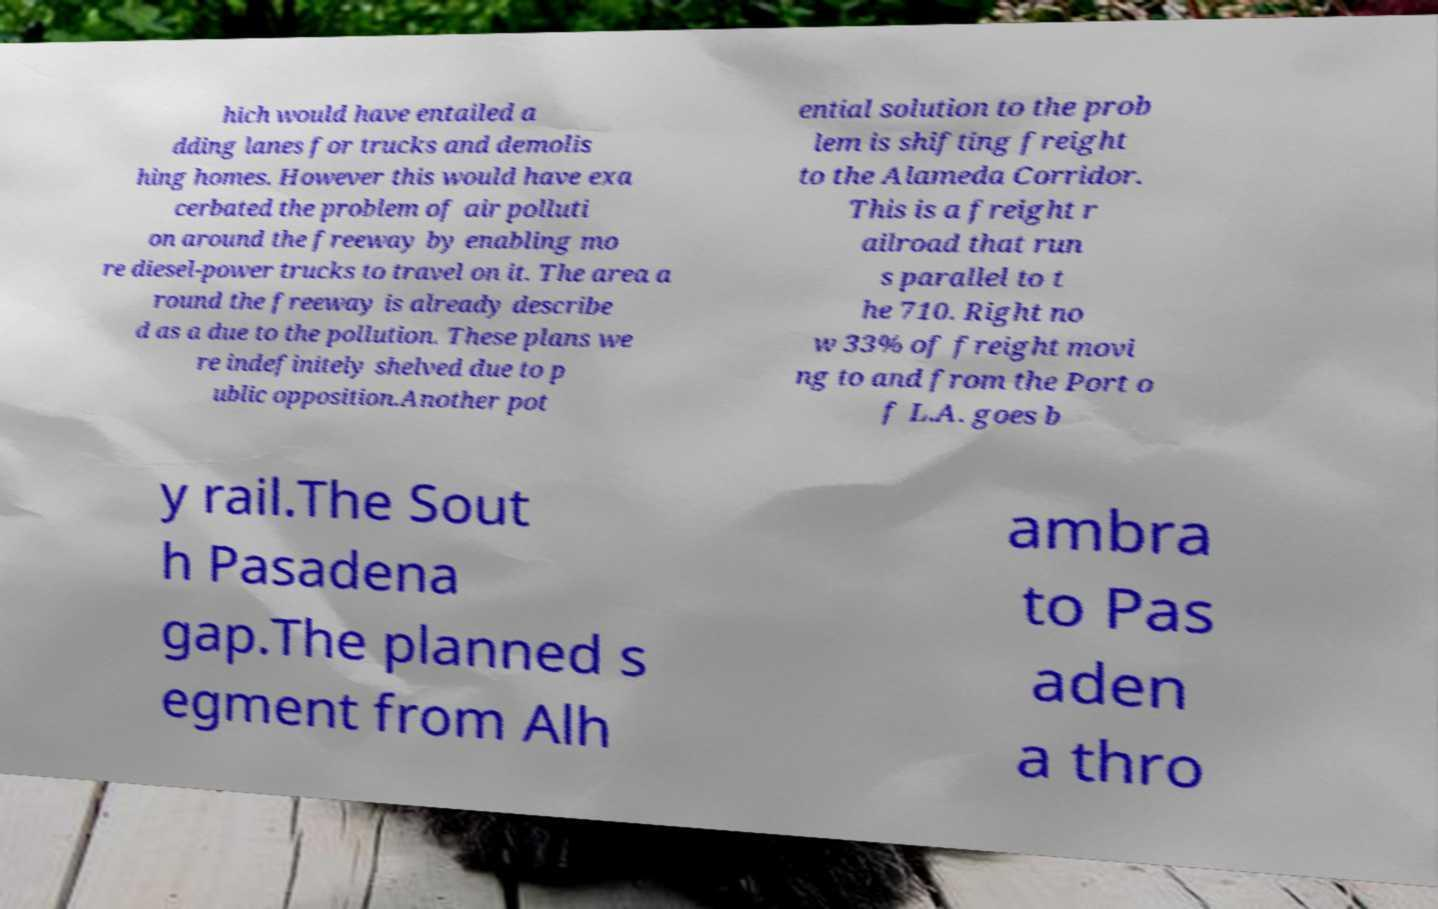Could you extract and type out the text from this image? hich would have entailed a dding lanes for trucks and demolis hing homes. However this would have exa cerbated the problem of air polluti on around the freeway by enabling mo re diesel-power trucks to travel on it. The area a round the freeway is already describe d as a due to the pollution. These plans we re indefinitely shelved due to p ublic opposition.Another pot ential solution to the prob lem is shifting freight to the Alameda Corridor. This is a freight r ailroad that run s parallel to t he 710. Right no w 33% of freight movi ng to and from the Port o f L.A. goes b y rail.The Sout h Pasadena gap.The planned s egment from Alh ambra to Pas aden a thro 